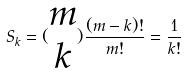<formula> <loc_0><loc_0><loc_500><loc_500>S _ { k } = ( \begin{matrix} m \\ k \end{matrix} ) \frac { ( m - k ) ! } { m ! } = \frac { 1 } { k ! }</formula> 